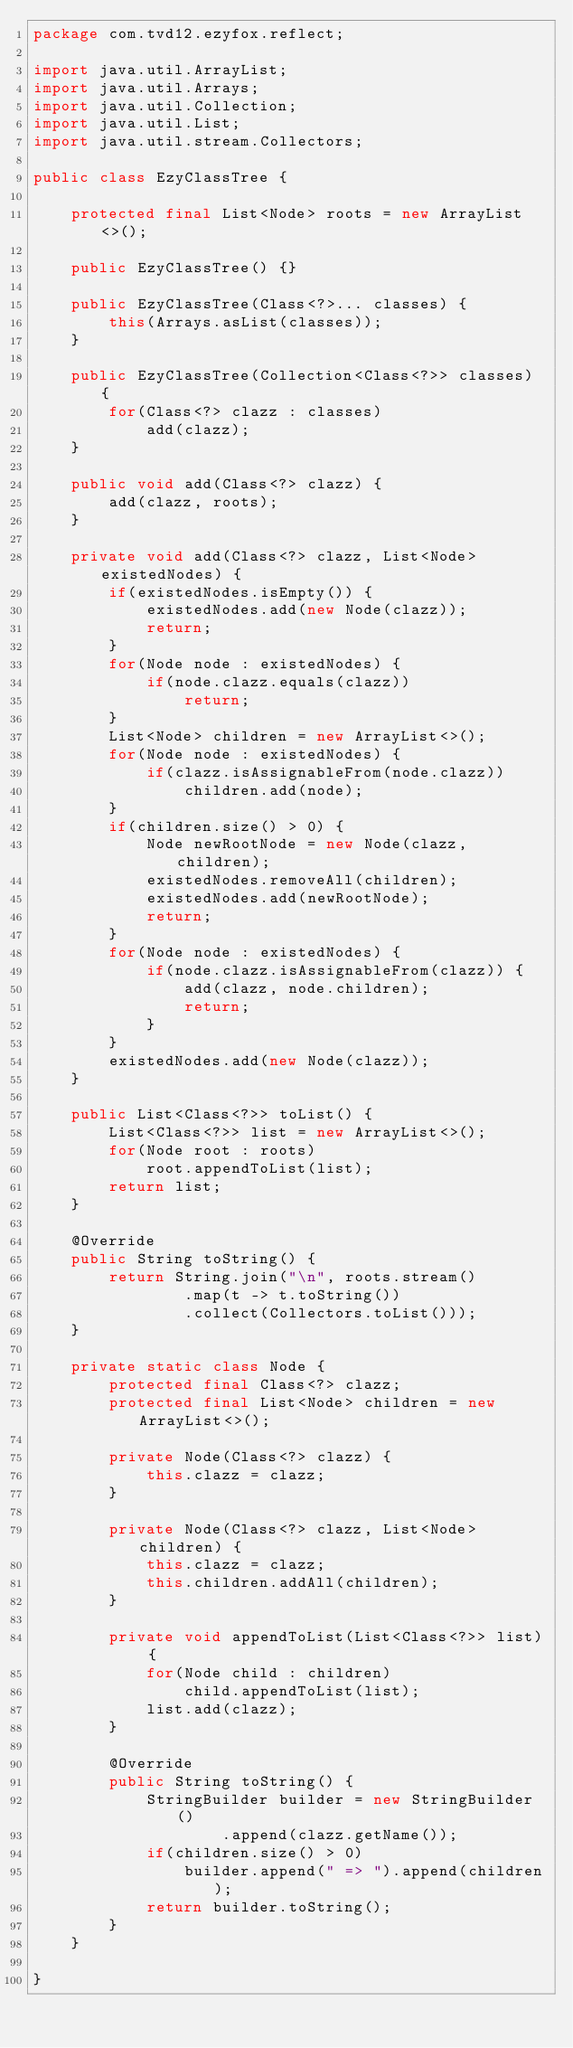<code> <loc_0><loc_0><loc_500><loc_500><_Java_>package com.tvd12.ezyfox.reflect;

import java.util.ArrayList;
import java.util.Arrays;
import java.util.Collection;
import java.util.List;
import java.util.stream.Collectors;

public class EzyClassTree {
	
	protected final List<Node> roots = new ArrayList<>();
	
	public EzyClassTree() {}
	
	public EzyClassTree(Class<?>... classes) {
		this(Arrays.asList(classes));
	}
	
	public EzyClassTree(Collection<Class<?>> classes) {
		for(Class<?> clazz : classes)
			add(clazz);
	}
	
	public void add(Class<?> clazz) {
		add(clazz, roots);
	}
	
	private void add(Class<?> clazz, List<Node> existedNodes) {
		if(existedNodes.isEmpty()) {
			existedNodes.add(new Node(clazz));
			return;
		}
		for(Node node : existedNodes) {
			if(node.clazz.equals(clazz))
				return;
		}
		List<Node> children = new ArrayList<>();
		for(Node node : existedNodes) {
			if(clazz.isAssignableFrom(node.clazz))
				children.add(node);
		}
		if(children.size() > 0) {
			Node newRootNode = new Node(clazz, children);
			existedNodes.removeAll(children);
			existedNodes.add(newRootNode);
			return;
		}
		for(Node node : existedNodes) {
			if(node.clazz.isAssignableFrom(clazz)) {
				add(clazz, node.children);
				return;
			}
		}
		existedNodes.add(new Node(clazz));
	}
	
	public List<Class<?>> toList() {
		List<Class<?>> list = new ArrayList<>();
		for(Node root : roots)
			root.appendToList(list);
		return list;
	}
	
	@Override
	public String toString() {
		return String.join("\n", roots.stream()
				.map(t -> t.toString())
				.collect(Collectors.toList()));
	}

	private static class Node {
		protected final Class<?> clazz;
		protected final List<Node> children = new ArrayList<>();
		
		private Node(Class<?> clazz) {
			this.clazz = clazz;
		}
		
		private Node(Class<?> clazz, List<Node> children) {
			this.clazz = clazz;
			this.children.addAll(children);
		}
		
		private void appendToList(List<Class<?>> list) {
			for(Node child : children)
				child.appendToList(list);
			list.add(clazz);
		}
		
		@Override
		public String toString() {
			StringBuilder builder = new StringBuilder()
					.append(clazz.getName());
			if(children.size() > 0)
				builder.append(" => ").append(children);
			return builder.toString();
		}
	}
	
}
</code> 